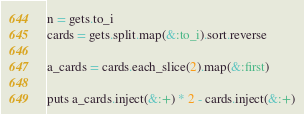Convert code to text. <code><loc_0><loc_0><loc_500><loc_500><_Ruby_>n = gets.to_i
cards = gets.split.map(&:to_i).sort.reverse

a_cards = cards.each_slice(2).map(&:first)

puts a_cards.inject(&:+) * 2 - cards.inject(&:+)</code> 